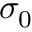Convert formula to latex. <formula><loc_0><loc_0><loc_500><loc_500>\sigma _ { 0 }</formula> 